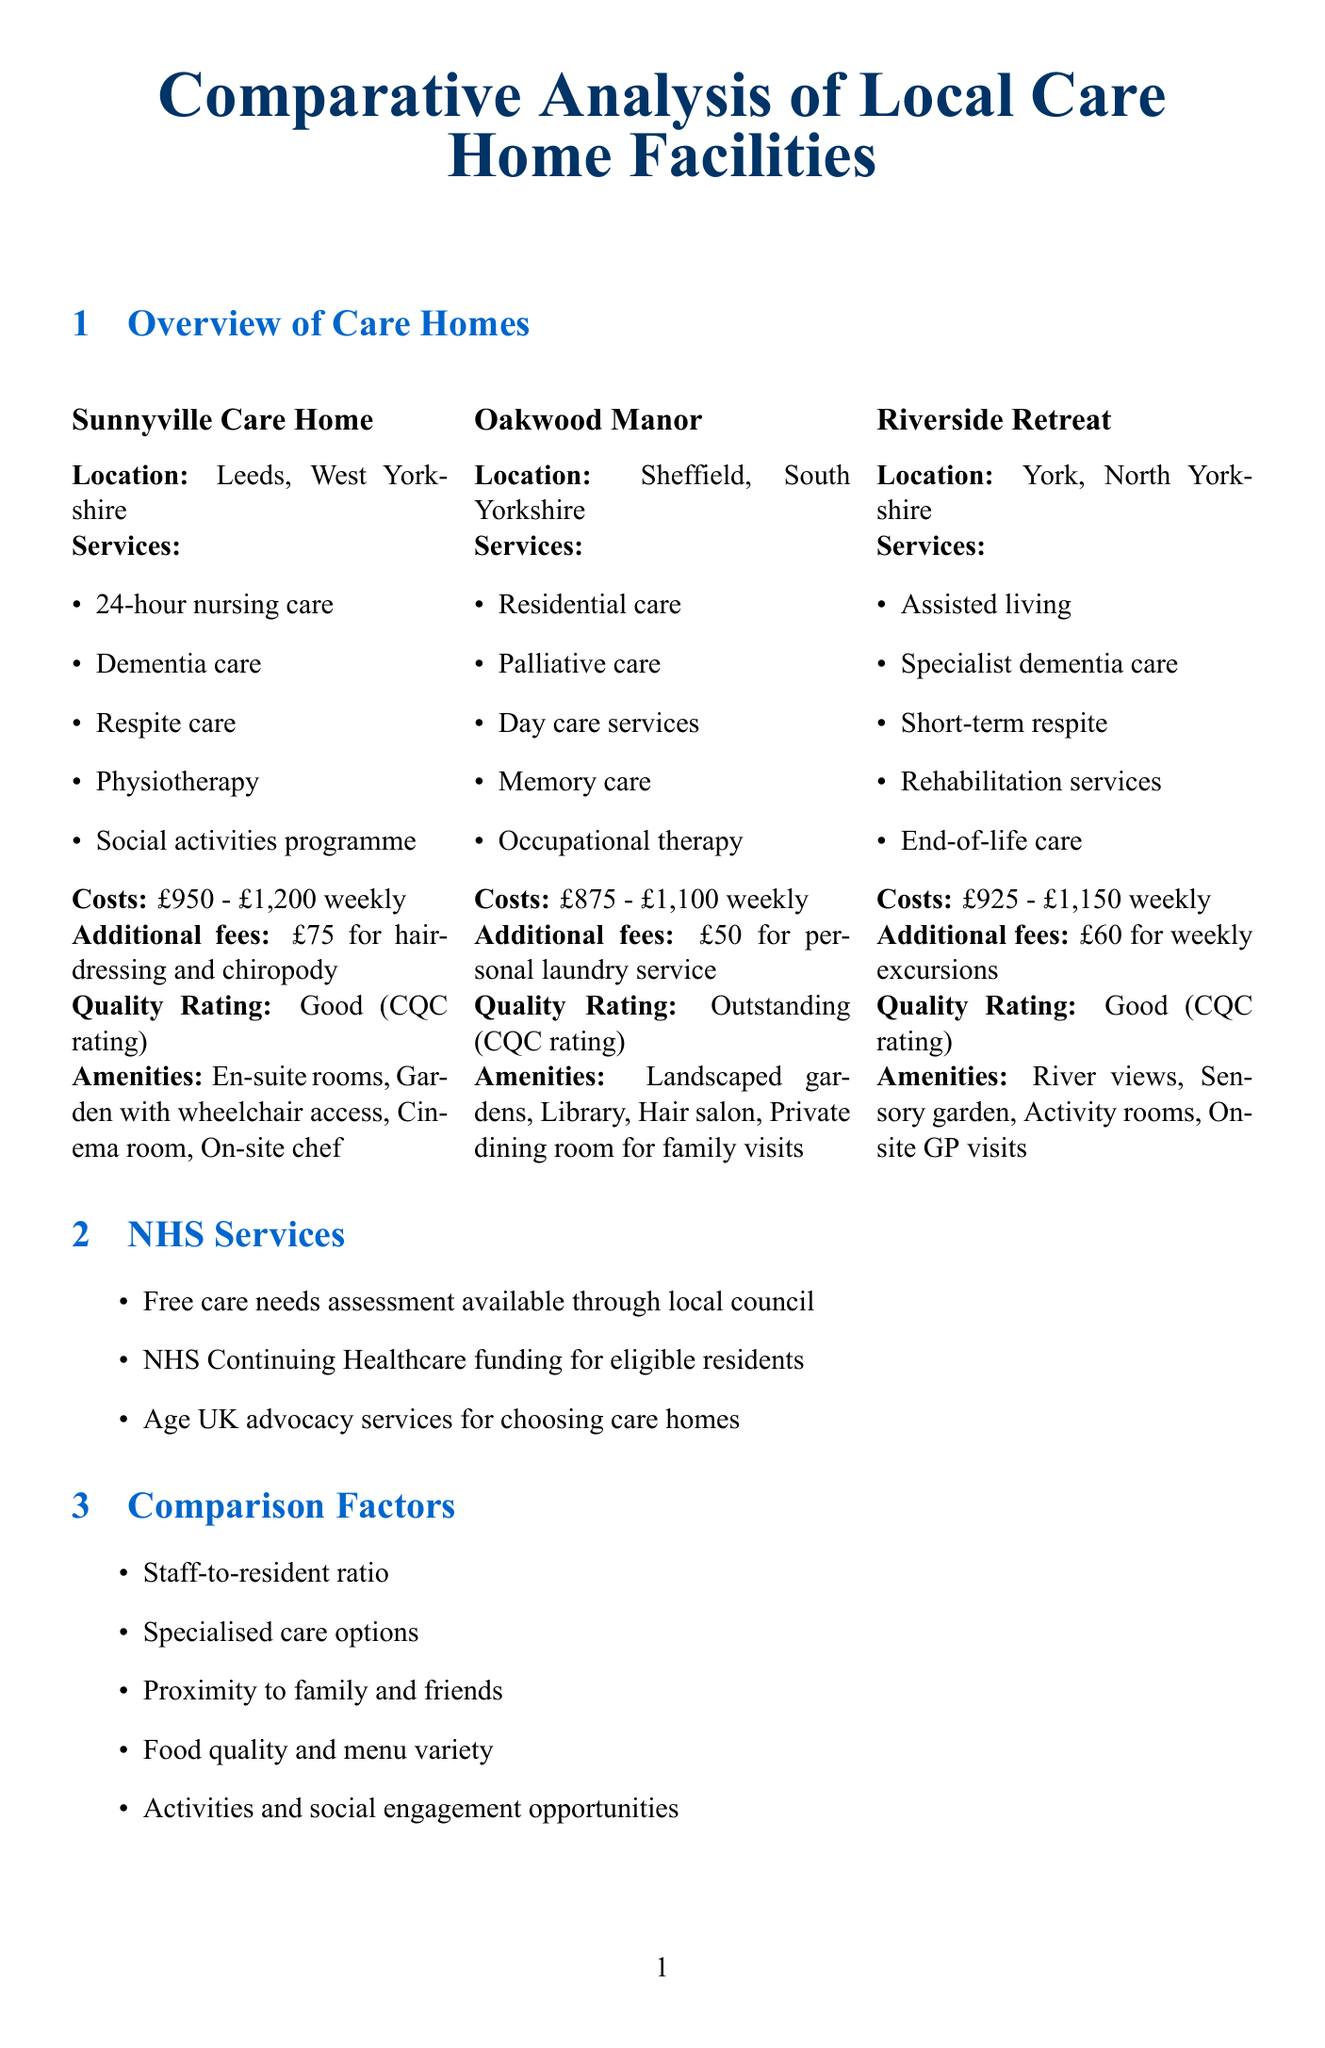what is the quality rating of Oakwood Manor? The quality rating for Oakwood Manor is stated as "Outstanding (CQC rating)" in the document.
Answer: Outstanding (CQC rating) what additional fee is charged at Sunnyville Care Home? The document outlines that Sunnyville Care Home has an additional fee of £75 for hairdressing and chiropody.
Answer: £75 for hairdressing and chiropody which care home offers 24-hour nursing care? Sunnyville Care Home is listed as offering 24-hour nursing care among its services.
Answer: Sunnyville Care Home what is the weekly rate range for Riverside Retreat? The document specifies that Riverside Retreat has a weekly rate range of £925 to £1,150.
Answer: £925 - £1,150 how many different types of care services are offered at Oakwood Manor? The document lists five different services available at Oakwood Manor: residential care, palliative care, day care services, memory care, and occupational therapy, indicating a total of five services.
Answer: 5 what is the savings threshold for self-funding in England? The document states the savings threshold for self-funding in England is £23,250.
Answer: £23,250 which care home's amenities include a cinema room? According to the document, Sunnyville Care Home includes a cinema room in its amenities.
Answer: Sunnyville Care Home does NHS provide funding for eligible residents? The document indicates that the NHS provides Continuing Healthcare funding for eligible residents, confirming the availability of such funding.
Answer: Yes, NHS Continuing Healthcare funding 